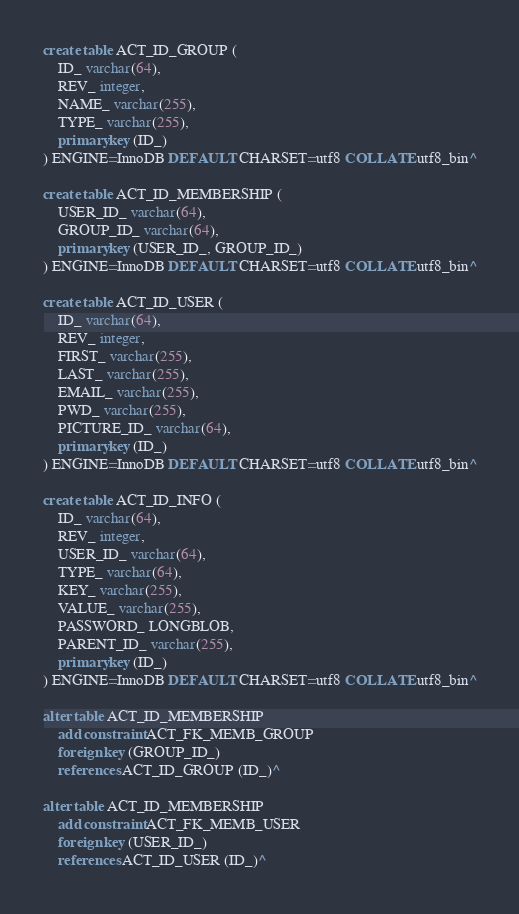<code> <loc_0><loc_0><loc_500><loc_500><_SQL_>create table ACT_ID_GROUP (
    ID_ varchar(64),
    REV_ integer,
    NAME_ varchar(255),
    TYPE_ varchar(255),
    primary key (ID_)
) ENGINE=InnoDB DEFAULT CHARSET=utf8 COLLATE utf8_bin^

create table ACT_ID_MEMBERSHIP (
    USER_ID_ varchar(64),
    GROUP_ID_ varchar(64),
    primary key (USER_ID_, GROUP_ID_)
) ENGINE=InnoDB DEFAULT CHARSET=utf8 COLLATE utf8_bin^

create table ACT_ID_USER (
    ID_ varchar(64),
    REV_ integer,
    FIRST_ varchar(255),
    LAST_ varchar(255),
    EMAIL_ varchar(255),
    PWD_ varchar(255),
    PICTURE_ID_ varchar(64),
    primary key (ID_)
) ENGINE=InnoDB DEFAULT CHARSET=utf8 COLLATE utf8_bin^

create table ACT_ID_INFO (
    ID_ varchar(64),
    REV_ integer,
    USER_ID_ varchar(64),
    TYPE_ varchar(64),
    KEY_ varchar(255),
    VALUE_ varchar(255),
    PASSWORD_ LONGBLOB,
    PARENT_ID_ varchar(255),
    primary key (ID_)
) ENGINE=InnoDB DEFAULT CHARSET=utf8 COLLATE utf8_bin^

alter table ACT_ID_MEMBERSHIP
    add constraint ACT_FK_MEMB_GROUP
    foreign key (GROUP_ID_)
    references ACT_ID_GROUP (ID_)^

alter table ACT_ID_MEMBERSHIP
    add constraint ACT_FK_MEMB_USER
    foreign key (USER_ID_)
    references ACT_ID_USER (ID_)^
</code> 